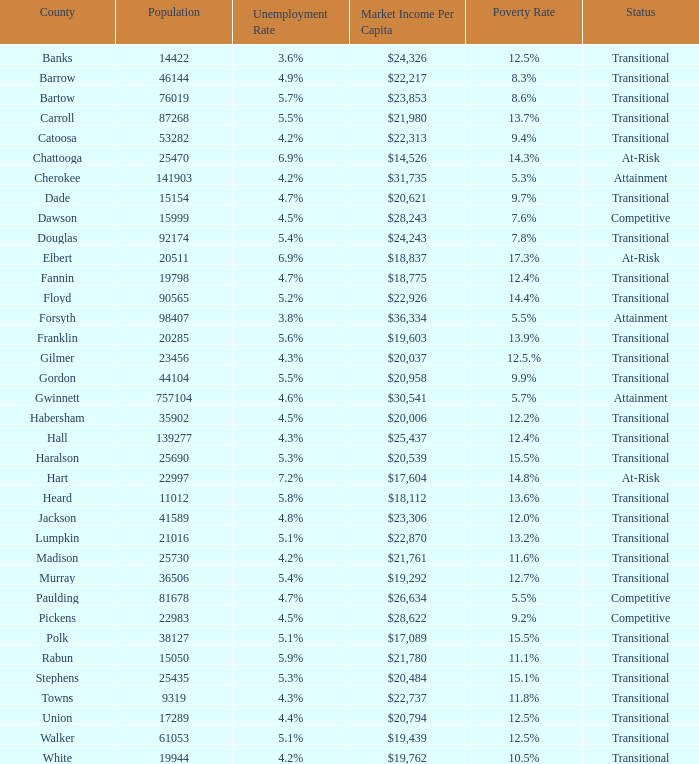What is the unemployment rate for the county with a market income per capita of $20,958? 1.0. 